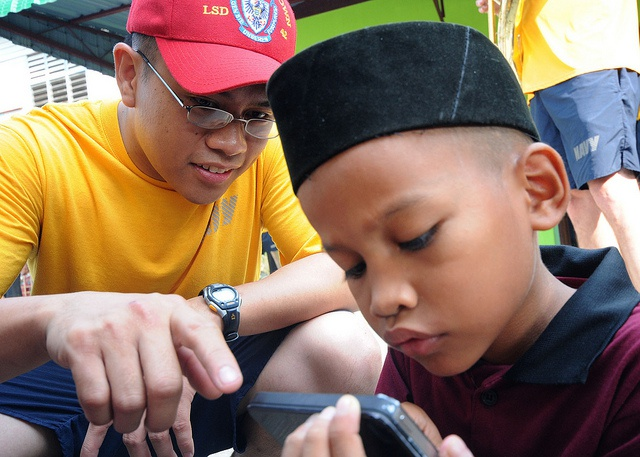Describe the objects in this image and their specific colors. I can see people in aquamarine, orange, lightgray, black, and brown tones, people in aquamarine, black, brown, tan, and maroon tones, people in aquamarine, ivory, darkgray, gray, and lightpink tones, cell phone in aquamarine, black, and gray tones, and cell phone in aquamarine, black, and brown tones in this image. 